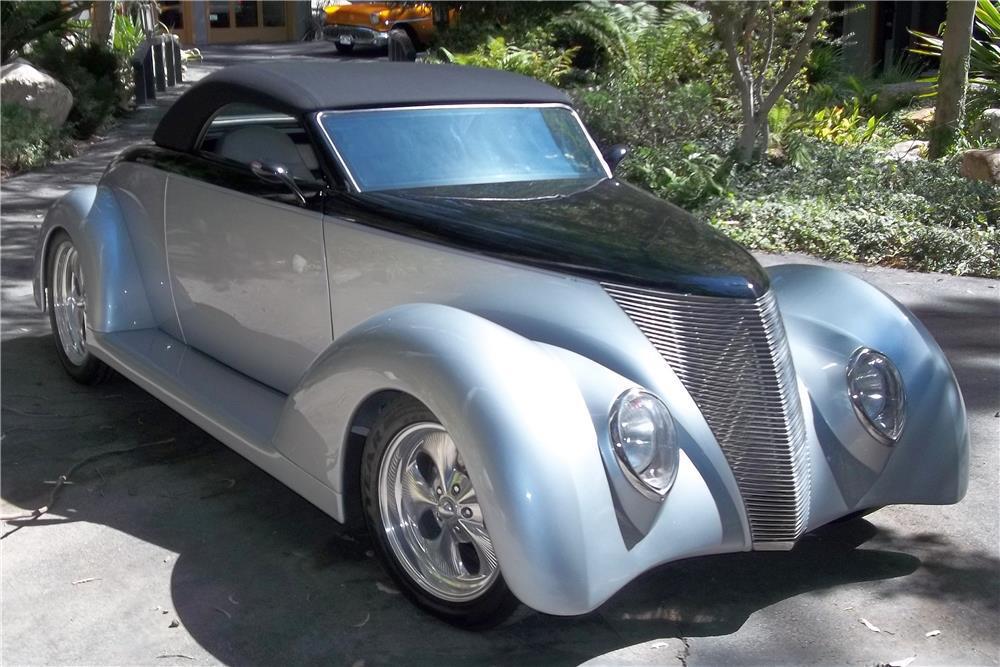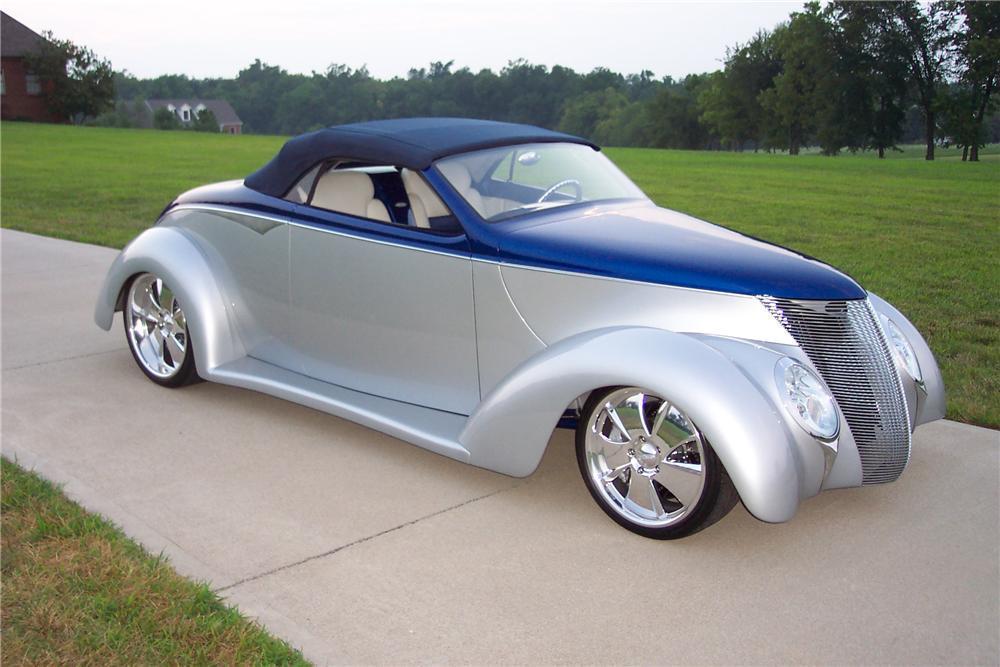The first image is the image on the left, the second image is the image on the right. Considering the images on both sides, is "The foreground cars in the left and right images face the same direction, and the righthand car is parked on a paved strip surrounded by grass and has a royal blue hood with a silver body." valid? Answer yes or no. Yes. The first image is the image on the left, the second image is the image on the right. Examine the images to the left and right. Is the description "One car has a tan roof" accurate? Answer yes or no. No. 